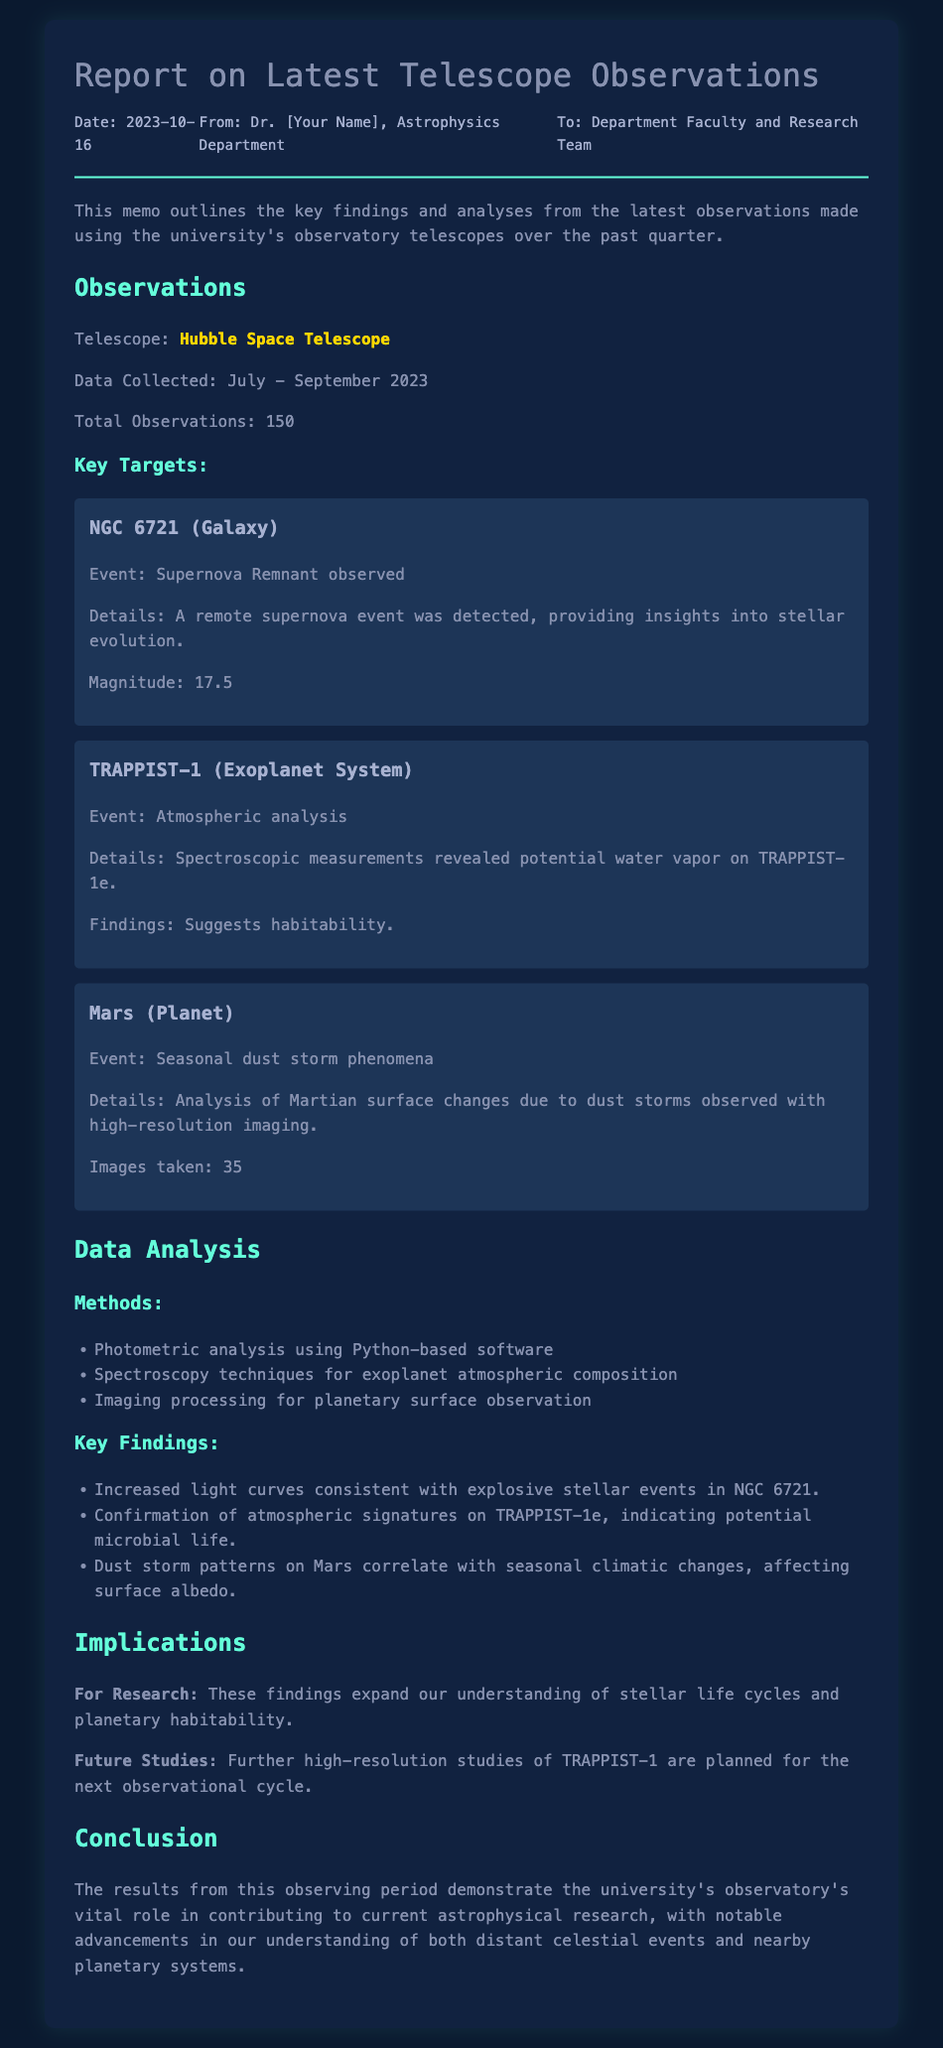What is the date of the report? The date of the report is mentioned in the header section.
Answer: 2023-10-16 How many total observations were made? This information is provided in the observations section of the document.
Answer: 150 What is the magnitude of the supernova remnant in NGC 6721? The magnitude is specifically stated in the details of the observations.
Answer: 17.5 What potential evidence for habitability was found in TRAPPIST-1e? This is noted in the observations section and concerns the findings from atmospheric analysis.
Answer: Water vapor Which telescope was used for the observations? The document specifies the telescope utilized in the observations.
Answer: Hubble Space Telescope What method was used for exoplanet atmospheric composition analysis? This method is listed in the data analysis section of the document.
Answer: Spectroscopy techniques What will be studied further in the next observational cycle? This information is available in the implications section, indicating future research focuses.
Answer: TRAPPIST-1 How many images were taken of Mars? This number is listed in the details of the Mars observations.
Answer: 35 What type of storm was observed on Mars? The event regarding Mars detailed in the observations section mentions the specific type of phenomena.
Answer: Dust storm 